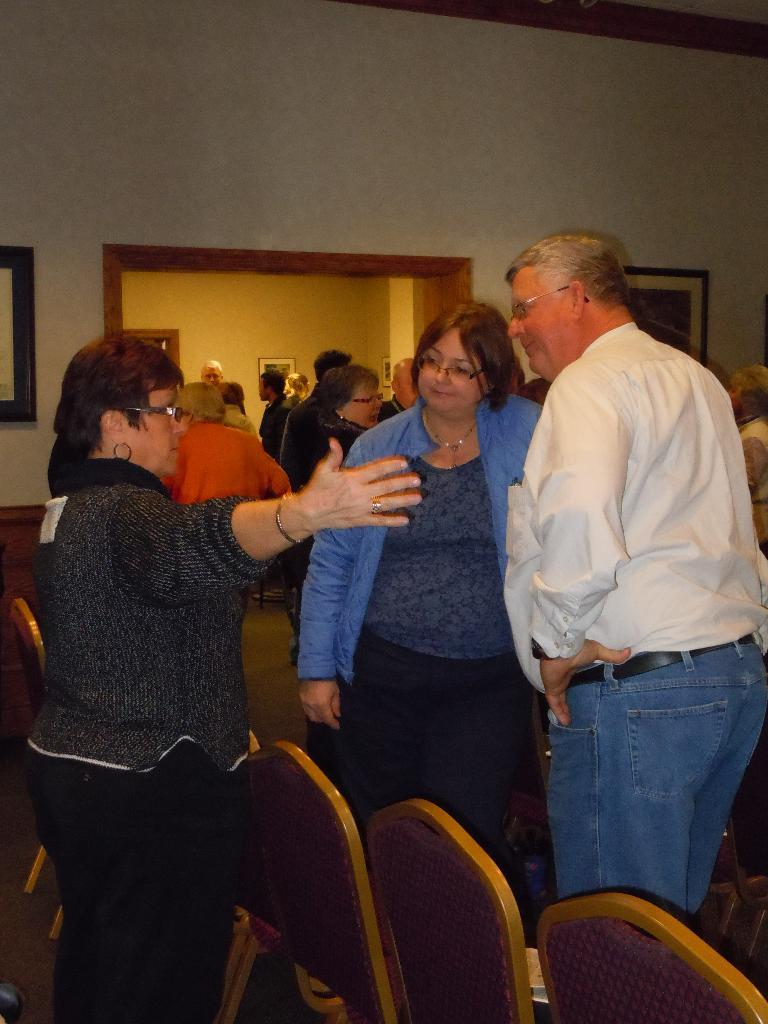What can be seen in the image involving people? There are people standing in the image. What type of furniture is present in the image? There are chairs in the image. What can be seen on the wall in the image? There are photo frames on the wall in the image. Where is the vase placed in the image? There is no vase present in the image. What type of sack can be seen being carried by one of the people in the image? There is no sack visible in the image, and no one is carrying anything. 